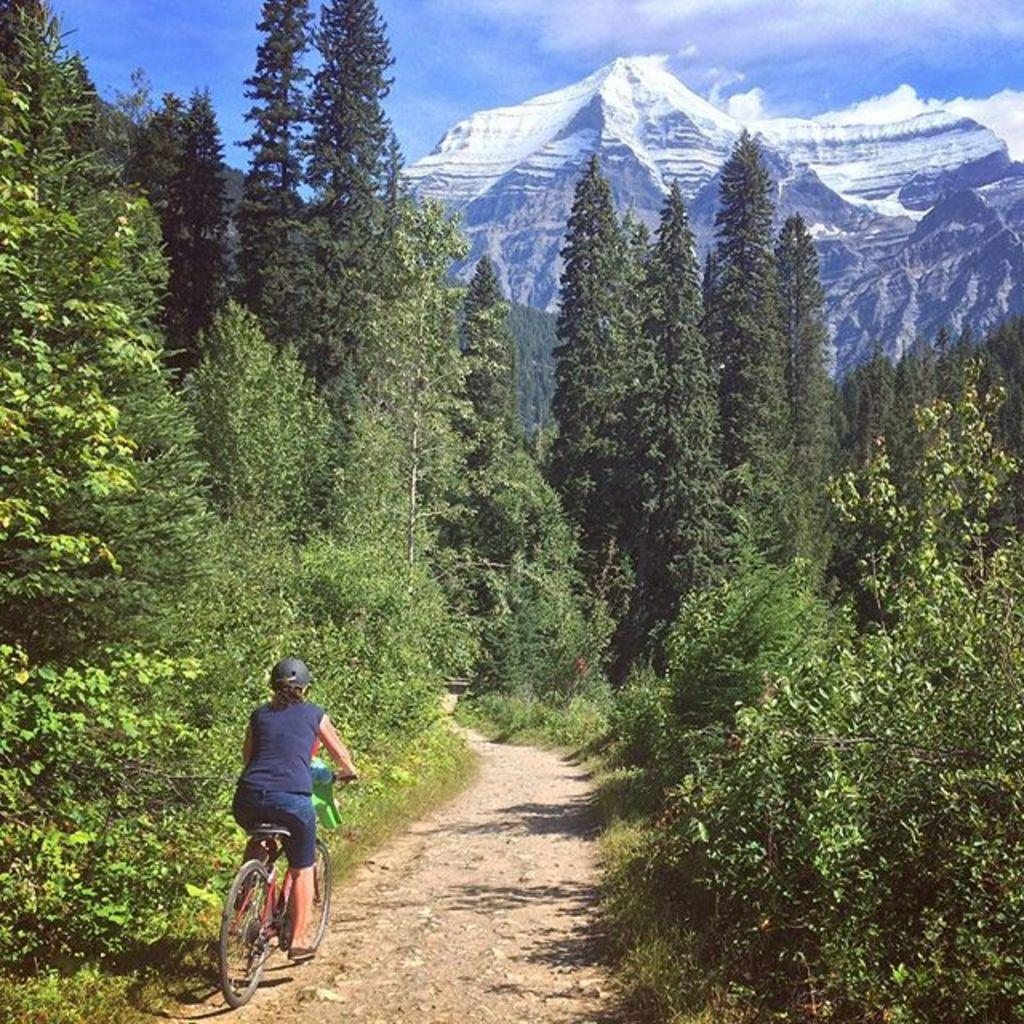What is the lady in the image doing? The lady is riding a bicycle in the image. What safety precaution is the lady taking while riding the bicycle? The lady is wearing a helmet. What can be seen in the background of the image? There are trees, mountains, and the sky visible in the background of the image. What type of cup is the lady holding while riding the bicycle? There is no cup present in the image; the lady is riding a bicycle and wearing a helmet. What color is the shirt the lady is wearing while riding the bicycle? The provided facts do not mention the color or type of shirt the lady is wearing. 